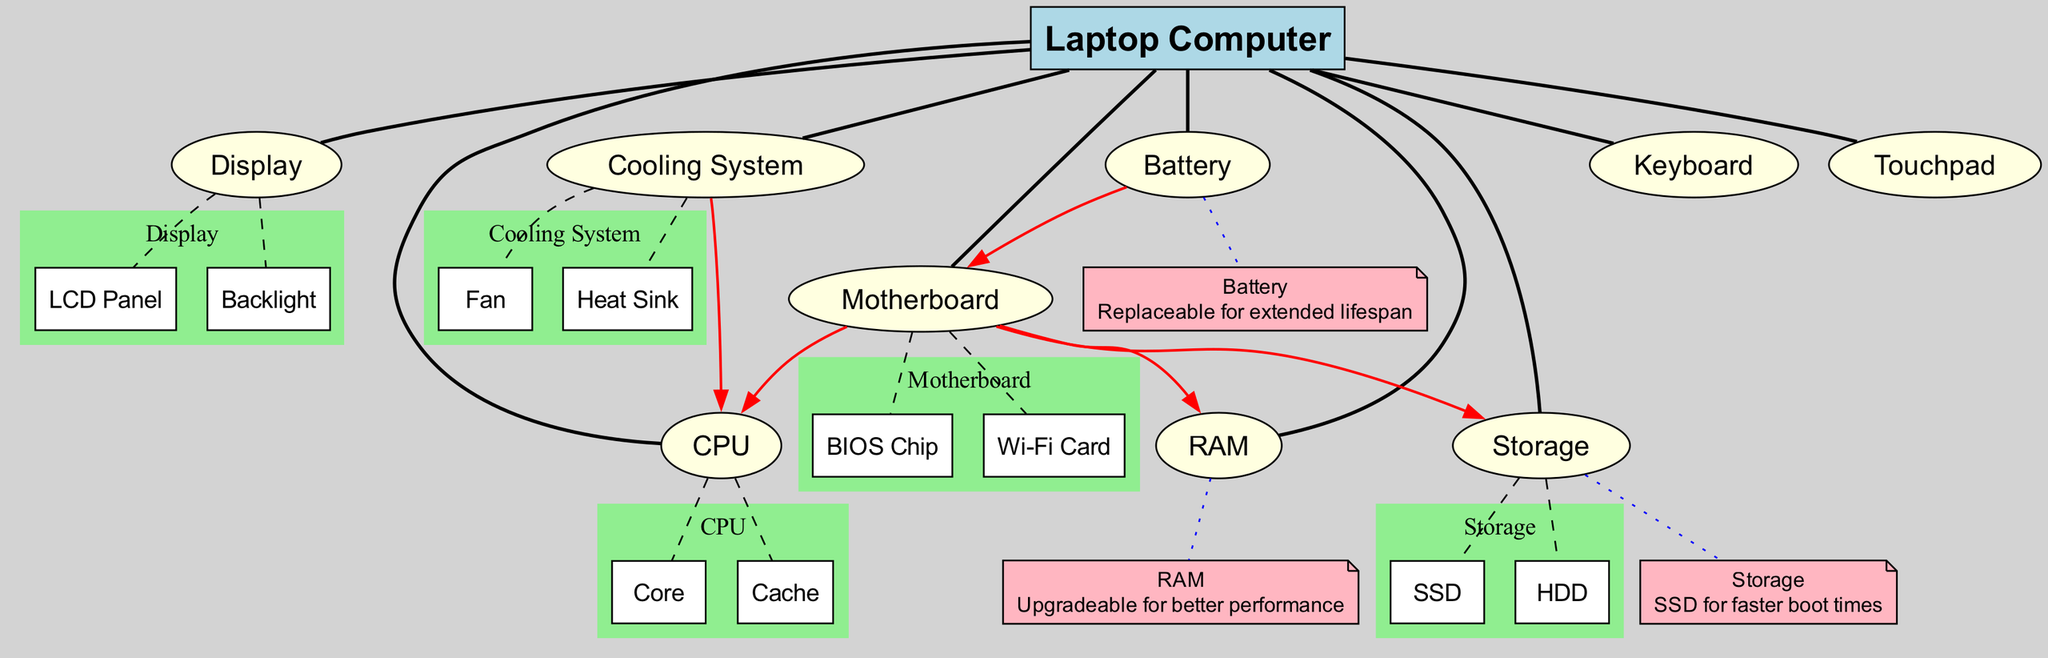What is the central node of the diagram? The diagram specifically identifies "Laptop Computer" as the central node. This is clearly outlined in the structure of the diagram, which emphasizes the laptop as the main subject.
Answer: Laptop Computer How many main components are shown in the diagram? The diagram lists a total of nine main components branching from the central node. A count of these components confirms this total.
Answer: Nine What component is connected to the CPU? The diagram shows that the "Motherboard" has a direct connection to the "CPU," illustrating the relationship between these two components.
Answer: Motherboard Which component is labeled as the storage type? Within the diagram, "Storage" is explicitly identified, and is further categorized into sub-components like "SSD" and "HDD," confirming its role as the storage type.
Answer: Storage How many sub-components are there for the Motherboard? The diagram provides two sub-components listed under "Motherboard," specifically "BIOS Chip" and "Wi-Fi Card," thus the total amount is two.
Answer: Two What is one budget tip associated with RAM? The diagram indicates a budget tip for "RAM," specifically noting its upgradeability for better performance, making it useful for users looking to boost their laptop's capabilities.
Answer: Upgradeable for better performance What is the connection from the Cooling System to the CPU? The diagram illustrates a forward direction connection from the "Cooling System" to the "CPU," indicating that the cooling system is designed to provide cooling to the CPU for optimal performance.
Answer: Forward connection How many components can be found in the Cooling System? The "Cooling System" in the diagram consists of two identified components: "Fan" and "Heat Sink," hence, the total number is two.
Answer: Two What color represents the sub-components in the diagram? In the diagram, sub-components are shaded a light green color within clusters, signifying their categorization under their respective main components.
Answer: Light green 